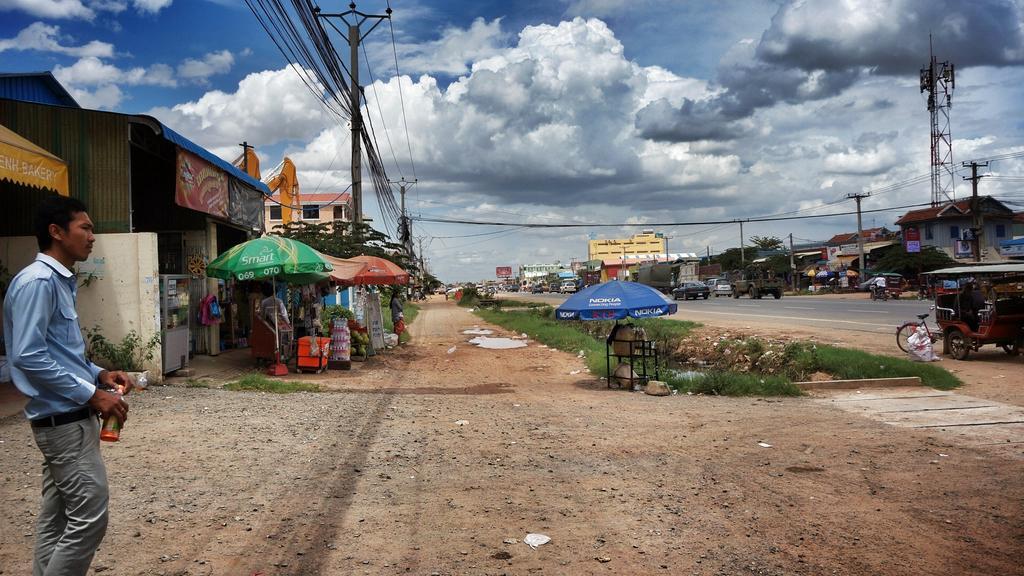Could you give a brief overview of what you see in this image? In this picture there are buildings on the right and left side of the image and there is a boy on the left side of the image, there is path in the center of the image. 